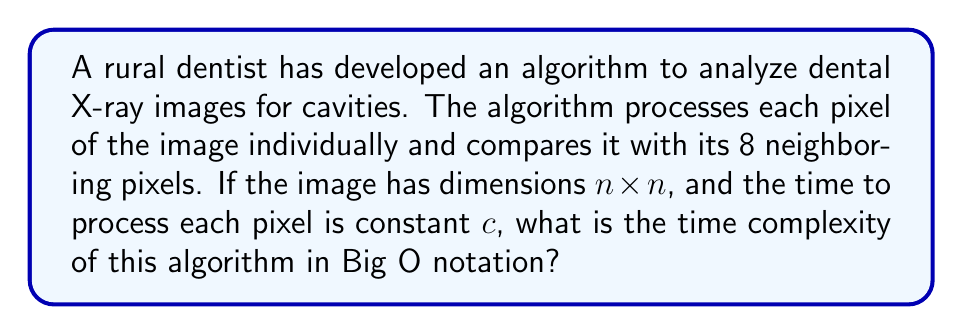What is the answer to this math problem? Let's approach this step-by-step:

1) First, we need to understand what the algorithm does:
   - It processes each pixel in an $n \times n$ image
   - For each pixel, it compares with 8 neighboring pixels
   - The time to process each pixel is constant $c$

2) Now, let's count the number of operations:
   - The image has $n \times n = n^2$ pixels in total
   - For each pixel, we perform 8 comparisons and some constant-time processing

3) So, for each pixel, we perform $8 + 1 = 9$ constant-time operations

4) The total number of operations is thus:
   $$ T(n) = 9c \cdot n^2 $$
   where $c$ is the constant time for each operation

5) In Big O notation, we drop constant factors and lower-order terms. Therefore:
   $$ T(n) = O(n^2) $$

6) This quadratic time complexity makes sense because we're processing every pixel in a two-dimensional image.
Answer: $O(n^2)$ 